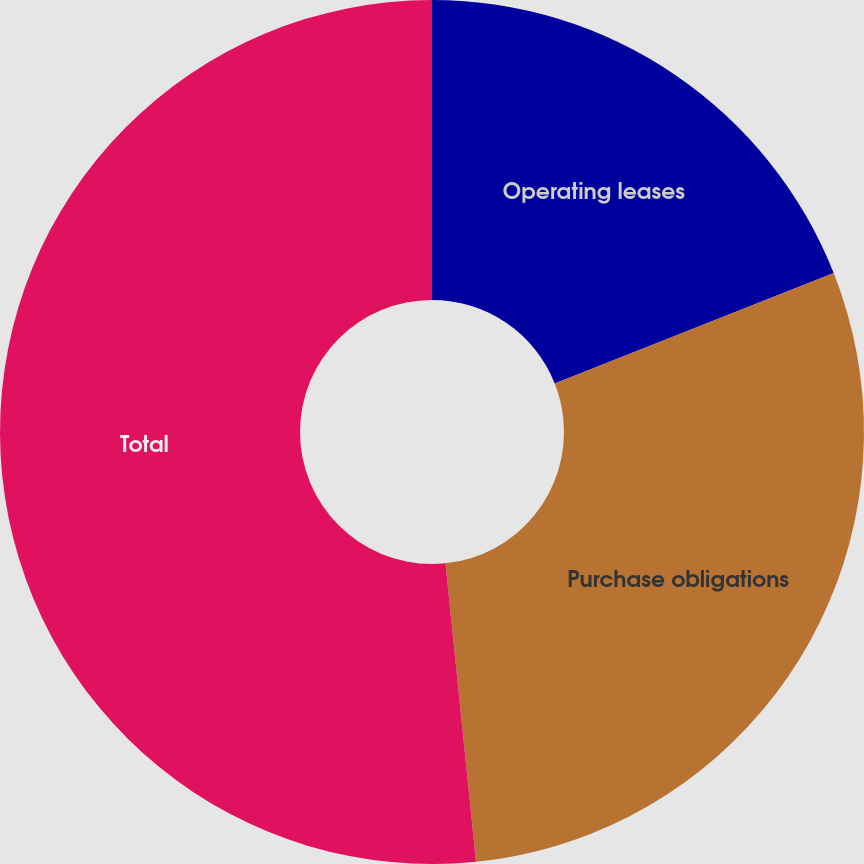Convert chart. <chart><loc_0><loc_0><loc_500><loc_500><pie_chart><fcel>Operating leases<fcel>Purchase obligations<fcel>Total<nl><fcel>19.0%<fcel>29.37%<fcel>51.62%<nl></chart> 